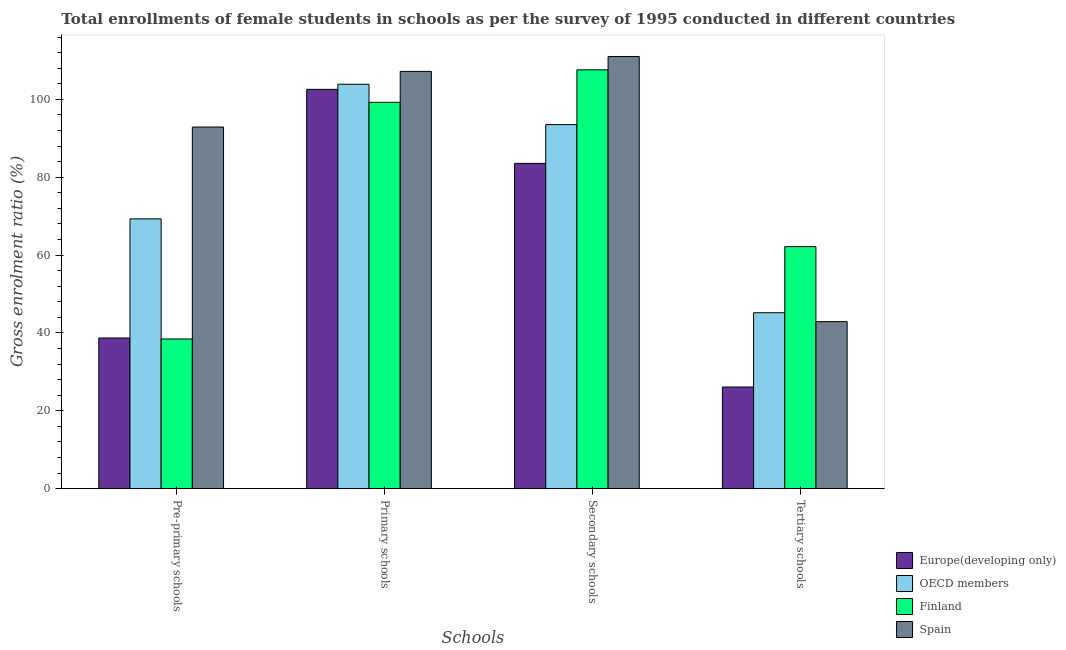Are the number of bars per tick equal to the number of legend labels?
Ensure brevity in your answer.  Yes. Are the number of bars on each tick of the X-axis equal?
Offer a terse response. Yes. How many bars are there on the 2nd tick from the right?
Your answer should be very brief. 4. What is the label of the 3rd group of bars from the left?
Offer a terse response. Secondary schools. What is the gross enrolment ratio(female) in primary schools in OECD members?
Make the answer very short. 103.9. Across all countries, what is the maximum gross enrolment ratio(female) in primary schools?
Ensure brevity in your answer.  107.2. Across all countries, what is the minimum gross enrolment ratio(female) in pre-primary schools?
Offer a terse response. 38.46. In which country was the gross enrolment ratio(female) in pre-primary schools minimum?
Your answer should be very brief. Finland. What is the total gross enrolment ratio(female) in tertiary schools in the graph?
Ensure brevity in your answer.  176.41. What is the difference between the gross enrolment ratio(female) in secondary schools in Finland and that in OECD members?
Your answer should be compact. 14.06. What is the difference between the gross enrolment ratio(female) in secondary schools in Europe(developing only) and the gross enrolment ratio(female) in tertiary schools in Finland?
Make the answer very short. 21.38. What is the average gross enrolment ratio(female) in pre-primary schools per country?
Give a very brief answer. 59.85. What is the difference between the gross enrolment ratio(female) in tertiary schools and gross enrolment ratio(female) in primary schools in Finland?
Ensure brevity in your answer.  -37.06. In how many countries, is the gross enrolment ratio(female) in primary schools greater than 80 %?
Give a very brief answer. 4. What is the ratio of the gross enrolment ratio(female) in tertiary schools in Finland to that in Europe(developing only)?
Make the answer very short. 2.38. What is the difference between the highest and the second highest gross enrolment ratio(female) in primary schools?
Your answer should be compact. 3.3. What is the difference between the highest and the lowest gross enrolment ratio(female) in tertiary schools?
Offer a very short reply. 36.08. Is it the case that in every country, the sum of the gross enrolment ratio(female) in pre-primary schools and gross enrolment ratio(female) in primary schools is greater than the gross enrolment ratio(female) in secondary schools?
Keep it short and to the point. Yes. How many bars are there?
Ensure brevity in your answer.  16. Are all the bars in the graph horizontal?
Ensure brevity in your answer.  No. Does the graph contain any zero values?
Provide a short and direct response. No. Where does the legend appear in the graph?
Your response must be concise. Bottom right. What is the title of the graph?
Offer a terse response. Total enrollments of female students in schools as per the survey of 1995 conducted in different countries. What is the label or title of the X-axis?
Ensure brevity in your answer.  Schools. What is the label or title of the Y-axis?
Your answer should be compact. Gross enrolment ratio (%). What is the Gross enrolment ratio (%) of Europe(developing only) in Pre-primary schools?
Offer a terse response. 38.71. What is the Gross enrolment ratio (%) of OECD members in Pre-primary schools?
Provide a short and direct response. 69.31. What is the Gross enrolment ratio (%) of Finland in Pre-primary schools?
Give a very brief answer. 38.46. What is the Gross enrolment ratio (%) in Spain in Pre-primary schools?
Keep it short and to the point. 92.9. What is the Gross enrolment ratio (%) in Europe(developing only) in Primary schools?
Offer a very short reply. 102.59. What is the Gross enrolment ratio (%) in OECD members in Primary schools?
Provide a short and direct response. 103.9. What is the Gross enrolment ratio (%) of Finland in Primary schools?
Ensure brevity in your answer.  99.25. What is the Gross enrolment ratio (%) of Spain in Primary schools?
Your answer should be compact. 107.2. What is the Gross enrolment ratio (%) in Europe(developing only) in Secondary schools?
Offer a very short reply. 83.57. What is the Gross enrolment ratio (%) of OECD members in Secondary schools?
Your response must be concise. 93.53. What is the Gross enrolment ratio (%) in Finland in Secondary schools?
Your answer should be compact. 107.6. What is the Gross enrolment ratio (%) of Spain in Secondary schools?
Your answer should be very brief. 111.03. What is the Gross enrolment ratio (%) in Europe(developing only) in Tertiary schools?
Your answer should be compact. 26.11. What is the Gross enrolment ratio (%) of OECD members in Tertiary schools?
Your answer should be very brief. 45.19. What is the Gross enrolment ratio (%) in Finland in Tertiary schools?
Ensure brevity in your answer.  62.19. What is the Gross enrolment ratio (%) in Spain in Tertiary schools?
Make the answer very short. 42.92. Across all Schools, what is the maximum Gross enrolment ratio (%) of Europe(developing only)?
Your answer should be very brief. 102.59. Across all Schools, what is the maximum Gross enrolment ratio (%) in OECD members?
Ensure brevity in your answer.  103.9. Across all Schools, what is the maximum Gross enrolment ratio (%) of Finland?
Keep it short and to the point. 107.6. Across all Schools, what is the maximum Gross enrolment ratio (%) in Spain?
Provide a short and direct response. 111.03. Across all Schools, what is the minimum Gross enrolment ratio (%) in Europe(developing only)?
Your answer should be very brief. 26.11. Across all Schools, what is the minimum Gross enrolment ratio (%) of OECD members?
Make the answer very short. 45.19. Across all Schools, what is the minimum Gross enrolment ratio (%) in Finland?
Offer a terse response. 38.46. Across all Schools, what is the minimum Gross enrolment ratio (%) in Spain?
Give a very brief answer. 42.92. What is the total Gross enrolment ratio (%) of Europe(developing only) in the graph?
Provide a succinct answer. 250.98. What is the total Gross enrolment ratio (%) in OECD members in the graph?
Your response must be concise. 311.94. What is the total Gross enrolment ratio (%) of Finland in the graph?
Provide a short and direct response. 307.49. What is the total Gross enrolment ratio (%) of Spain in the graph?
Your answer should be compact. 354.05. What is the difference between the Gross enrolment ratio (%) in Europe(developing only) in Pre-primary schools and that in Primary schools?
Keep it short and to the point. -63.88. What is the difference between the Gross enrolment ratio (%) in OECD members in Pre-primary schools and that in Primary schools?
Offer a terse response. -34.58. What is the difference between the Gross enrolment ratio (%) of Finland in Pre-primary schools and that in Primary schools?
Offer a terse response. -60.79. What is the difference between the Gross enrolment ratio (%) of Spain in Pre-primary schools and that in Primary schools?
Your response must be concise. -14.3. What is the difference between the Gross enrolment ratio (%) of Europe(developing only) in Pre-primary schools and that in Secondary schools?
Offer a very short reply. -44.85. What is the difference between the Gross enrolment ratio (%) of OECD members in Pre-primary schools and that in Secondary schools?
Offer a terse response. -24.22. What is the difference between the Gross enrolment ratio (%) of Finland in Pre-primary schools and that in Secondary schools?
Provide a short and direct response. -69.14. What is the difference between the Gross enrolment ratio (%) of Spain in Pre-primary schools and that in Secondary schools?
Give a very brief answer. -18.13. What is the difference between the Gross enrolment ratio (%) in Europe(developing only) in Pre-primary schools and that in Tertiary schools?
Make the answer very short. 12.6. What is the difference between the Gross enrolment ratio (%) of OECD members in Pre-primary schools and that in Tertiary schools?
Keep it short and to the point. 24.12. What is the difference between the Gross enrolment ratio (%) of Finland in Pre-primary schools and that in Tertiary schools?
Keep it short and to the point. -23.73. What is the difference between the Gross enrolment ratio (%) in Spain in Pre-primary schools and that in Tertiary schools?
Make the answer very short. 49.98. What is the difference between the Gross enrolment ratio (%) in Europe(developing only) in Primary schools and that in Secondary schools?
Keep it short and to the point. 19.02. What is the difference between the Gross enrolment ratio (%) in OECD members in Primary schools and that in Secondary schools?
Your response must be concise. 10.36. What is the difference between the Gross enrolment ratio (%) in Finland in Primary schools and that in Secondary schools?
Your answer should be compact. -8.35. What is the difference between the Gross enrolment ratio (%) in Spain in Primary schools and that in Secondary schools?
Provide a succinct answer. -3.83. What is the difference between the Gross enrolment ratio (%) of Europe(developing only) in Primary schools and that in Tertiary schools?
Offer a terse response. 76.48. What is the difference between the Gross enrolment ratio (%) in OECD members in Primary schools and that in Tertiary schools?
Your response must be concise. 58.7. What is the difference between the Gross enrolment ratio (%) of Finland in Primary schools and that in Tertiary schools?
Your answer should be compact. 37.06. What is the difference between the Gross enrolment ratio (%) in Spain in Primary schools and that in Tertiary schools?
Ensure brevity in your answer.  64.28. What is the difference between the Gross enrolment ratio (%) in Europe(developing only) in Secondary schools and that in Tertiary schools?
Ensure brevity in your answer.  57.45. What is the difference between the Gross enrolment ratio (%) of OECD members in Secondary schools and that in Tertiary schools?
Offer a very short reply. 48.34. What is the difference between the Gross enrolment ratio (%) of Finland in Secondary schools and that in Tertiary schools?
Your response must be concise. 45.41. What is the difference between the Gross enrolment ratio (%) of Spain in Secondary schools and that in Tertiary schools?
Keep it short and to the point. 68.11. What is the difference between the Gross enrolment ratio (%) in Europe(developing only) in Pre-primary schools and the Gross enrolment ratio (%) in OECD members in Primary schools?
Make the answer very short. -65.19. What is the difference between the Gross enrolment ratio (%) in Europe(developing only) in Pre-primary schools and the Gross enrolment ratio (%) in Finland in Primary schools?
Your response must be concise. -60.54. What is the difference between the Gross enrolment ratio (%) in Europe(developing only) in Pre-primary schools and the Gross enrolment ratio (%) in Spain in Primary schools?
Provide a succinct answer. -68.49. What is the difference between the Gross enrolment ratio (%) in OECD members in Pre-primary schools and the Gross enrolment ratio (%) in Finland in Primary schools?
Your answer should be compact. -29.94. What is the difference between the Gross enrolment ratio (%) in OECD members in Pre-primary schools and the Gross enrolment ratio (%) in Spain in Primary schools?
Offer a very short reply. -37.89. What is the difference between the Gross enrolment ratio (%) in Finland in Pre-primary schools and the Gross enrolment ratio (%) in Spain in Primary schools?
Keep it short and to the point. -68.74. What is the difference between the Gross enrolment ratio (%) in Europe(developing only) in Pre-primary schools and the Gross enrolment ratio (%) in OECD members in Secondary schools?
Keep it short and to the point. -54.82. What is the difference between the Gross enrolment ratio (%) of Europe(developing only) in Pre-primary schools and the Gross enrolment ratio (%) of Finland in Secondary schools?
Provide a short and direct response. -68.89. What is the difference between the Gross enrolment ratio (%) of Europe(developing only) in Pre-primary schools and the Gross enrolment ratio (%) of Spain in Secondary schools?
Your answer should be very brief. -72.32. What is the difference between the Gross enrolment ratio (%) of OECD members in Pre-primary schools and the Gross enrolment ratio (%) of Finland in Secondary schools?
Offer a very short reply. -38.29. What is the difference between the Gross enrolment ratio (%) of OECD members in Pre-primary schools and the Gross enrolment ratio (%) of Spain in Secondary schools?
Ensure brevity in your answer.  -41.72. What is the difference between the Gross enrolment ratio (%) of Finland in Pre-primary schools and the Gross enrolment ratio (%) of Spain in Secondary schools?
Offer a very short reply. -72.57. What is the difference between the Gross enrolment ratio (%) of Europe(developing only) in Pre-primary schools and the Gross enrolment ratio (%) of OECD members in Tertiary schools?
Your answer should be very brief. -6.48. What is the difference between the Gross enrolment ratio (%) in Europe(developing only) in Pre-primary schools and the Gross enrolment ratio (%) in Finland in Tertiary schools?
Offer a terse response. -23.48. What is the difference between the Gross enrolment ratio (%) of Europe(developing only) in Pre-primary schools and the Gross enrolment ratio (%) of Spain in Tertiary schools?
Your response must be concise. -4.21. What is the difference between the Gross enrolment ratio (%) in OECD members in Pre-primary schools and the Gross enrolment ratio (%) in Finland in Tertiary schools?
Provide a succinct answer. 7.12. What is the difference between the Gross enrolment ratio (%) of OECD members in Pre-primary schools and the Gross enrolment ratio (%) of Spain in Tertiary schools?
Make the answer very short. 26.39. What is the difference between the Gross enrolment ratio (%) of Finland in Pre-primary schools and the Gross enrolment ratio (%) of Spain in Tertiary schools?
Make the answer very short. -4.46. What is the difference between the Gross enrolment ratio (%) of Europe(developing only) in Primary schools and the Gross enrolment ratio (%) of OECD members in Secondary schools?
Ensure brevity in your answer.  9.05. What is the difference between the Gross enrolment ratio (%) of Europe(developing only) in Primary schools and the Gross enrolment ratio (%) of Finland in Secondary schools?
Ensure brevity in your answer.  -5.01. What is the difference between the Gross enrolment ratio (%) in Europe(developing only) in Primary schools and the Gross enrolment ratio (%) in Spain in Secondary schools?
Offer a terse response. -8.44. What is the difference between the Gross enrolment ratio (%) in OECD members in Primary schools and the Gross enrolment ratio (%) in Finland in Secondary schools?
Your response must be concise. -3.7. What is the difference between the Gross enrolment ratio (%) in OECD members in Primary schools and the Gross enrolment ratio (%) in Spain in Secondary schools?
Offer a terse response. -7.13. What is the difference between the Gross enrolment ratio (%) in Finland in Primary schools and the Gross enrolment ratio (%) in Spain in Secondary schools?
Offer a very short reply. -11.78. What is the difference between the Gross enrolment ratio (%) of Europe(developing only) in Primary schools and the Gross enrolment ratio (%) of OECD members in Tertiary schools?
Make the answer very short. 57.39. What is the difference between the Gross enrolment ratio (%) in Europe(developing only) in Primary schools and the Gross enrolment ratio (%) in Finland in Tertiary schools?
Your answer should be compact. 40.4. What is the difference between the Gross enrolment ratio (%) in Europe(developing only) in Primary schools and the Gross enrolment ratio (%) in Spain in Tertiary schools?
Your answer should be compact. 59.67. What is the difference between the Gross enrolment ratio (%) of OECD members in Primary schools and the Gross enrolment ratio (%) of Finland in Tertiary schools?
Provide a succinct answer. 41.71. What is the difference between the Gross enrolment ratio (%) of OECD members in Primary schools and the Gross enrolment ratio (%) of Spain in Tertiary schools?
Give a very brief answer. 60.98. What is the difference between the Gross enrolment ratio (%) in Finland in Primary schools and the Gross enrolment ratio (%) in Spain in Tertiary schools?
Make the answer very short. 56.33. What is the difference between the Gross enrolment ratio (%) of Europe(developing only) in Secondary schools and the Gross enrolment ratio (%) of OECD members in Tertiary schools?
Offer a very short reply. 38.37. What is the difference between the Gross enrolment ratio (%) of Europe(developing only) in Secondary schools and the Gross enrolment ratio (%) of Finland in Tertiary schools?
Offer a very short reply. 21.38. What is the difference between the Gross enrolment ratio (%) of Europe(developing only) in Secondary schools and the Gross enrolment ratio (%) of Spain in Tertiary schools?
Your answer should be compact. 40.65. What is the difference between the Gross enrolment ratio (%) of OECD members in Secondary schools and the Gross enrolment ratio (%) of Finland in Tertiary schools?
Your answer should be very brief. 31.34. What is the difference between the Gross enrolment ratio (%) of OECD members in Secondary schools and the Gross enrolment ratio (%) of Spain in Tertiary schools?
Your response must be concise. 50.62. What is the difference between the Gross enrolment ratio (%) in Finland in Secondary schools and the Gross enrolment ratio (%) in Spain in Tertiary schools?
Offer a terse response. 64.68. What is the average Gross enrolment ratio (%) of Europe(developing only) per Schools?
Offer a terse response. 62.74. What is the average Gross enrolment ratio (%) in OECD members per Schools?
Provide a short and direct response. 77.98. What is the average Gross enrolment ratio (%) of Finland per Schools?
Offer a very short reply. 76.87. What is the average Gross enrolment ratio (%) in Spain per Schools?
Your response must be concise. 88.51. What is the difference between the Gross enrolment ratio (%) of Europe(developing only) and Gross enrolment ratio (%) of OECD members in Pre-primary schools?
Make the answer very short. -30.6. What is the difference between the Gross enrolment ratio (%) in Europe(developing only) and Gross enrolment ratio (%) in Finland in Pre-primary schools?
Ensure brevity in your answer.  0.25. What is the difference between the Gross enrolment ratio (%) in Europe(developing only) and Gross enrolment ratio (%) in Spain in Pre-primary schools?
Provide a short and direct response. -54.19. What is the difference between the Gross enrolment ratio (%) in OECD members and Gross enrolment ratio (%) in Finland in Pre-primary schools?
Your answer should be compact. 30.86. What is the difference between the Gross enrolment ratio (%) of OECD members and Gross enrolment ratio (%) of Spain in Pre-primary schools?
Your answer should be very brief. -23.59. What is the difference between the Gross enrolment ratio (%) of Finland and Gross enrolment ratio (%) of Spain in Pre-primary schools?
Your answer should be very brief. -54.45. What is the difference between the Gross enrolment ratio (%) of Europe(developing only) and Gross enrolment ratio (%) of OECD members in Primary schools?
Offer a terse response. -1.31. What is the difference between the Gross enrolment ratio (%) in Europe(developing only) and Gross enrolment ratio (%) in Finland in Primary schools?
Keep it short and to the point. 3.34. What is the difference between the Gross enrolment ratio (%) in Europe(developing only) and Gross enrolment ratio (%) in Spain in Primary schools?
Your answer should be compact. -4.61. What is the difference between the Gross enrolment ratio (%) of OECD members and Gross enrolment ratio (%) of Finland in Primary schools?
Ensure brevity in your answer.  4.65. What is the difference between the Gross enrolment ratio (%) of OECD members and Gross enrolment ratio (%) of Spain in Primary schools?
Your answer should be very brief. -3.3. What is the difference between the Gross enrolment ratio (%) of Finland and Gross enrolment ratio (%) of Spain in Primary schools?
Offer a very short reply. -7.95. What is the difference between the Gross enrolment ratio (%) in Europe(developing only) and Gross enrolment ratio (%) in OECD members in Secondary schools?
Your answer should be compact. -9.97. What is the difference between the Gross enrolment ratio (%) in Europe(developing only) and Gross enrolment ratio (%) in Finland in Secondary schools?
Provide a succinct answer. -24.03. What is the difference between the Gross enrolment ratio (%) in Europe(developing only) and Gross enrolment ratio (%) in Spain in Secondary schools?
Offer a terse response. -27.46. What is the difference between the Gross enrolment ratio (%) in OECD members and Gross enrolment ratio (%) in Finland in Secondary schools?
Your answer should be compact. -14.06. What is the difference between the Gross enrolment ratio (%) of OECD members and Gross enrolment ratio (%) of Spain in Secondary schools?
Ensure brevity in your answer.  -17.49. What is the difference between the Gross enrolment ratio (%) in Finland and Gross enrolment ratio (%) in Spain in Secondary schools?
Provide a short and direct response. -3.43. What is the difference between the Gross enrolment ratio (%) of Europe(developing only) and Gross enrolment ratio (%) of OECD members in Tertiary schools?
Your response must be concise. -19.08. What is the difference between the Gross enrolment ratio (%) of Europe(developing only) and Gross enrolment ratio (%) of Finland in Tertiary schools?
Keep it short and to the point. -36.08. What is the difference between the Gross enrolment ratio (%) in Europe(developing only) and Gross enrolment ratio (%) in Spain in Tertiary schools?
Your response must be concise. -16.81. What is the difference between the Gross enrolment ratio (%) in OECD members and Gross enrolment ratio (%) in Finland in Tertiary schools?
Ensure brevity in your answer.  -16.99. What is the difference between the Gross enrolment ratio (%) in OECD members and Gross enrolment ratio (%) in Spain in Tertiary schools?
Make the answer very short. 2.28. What is the difference between the Gross enrolment ratio (%) in Finland and Gross enrolment ratio (%) in Spain in Tertiary schools?
Your answer should be compact. 19.27. What is the ratio of the Gross enrolment ratio (%) in Europe(developing only) in Pre-primary schools to that in Primary schools?
Offer a very short reply. 0.38. What is the ratio of the Gross enrolment ratio (%) of OECD members in Pre-primary schools to that in Primary schools?
Your answer should be compact. 0.67. What is the ratio of the Gross enrolment ratio (%) in Finland in Pre-primary schools to that in Primary schools?
Your answer should be compact. 0.39. What is the ratio of the Gross enrolment ratio (%) in Spain in Pre-primary schools to that in Primary schools?
Offer a very short reply. 0.87. What is the ratio of the Gross enrolment ratio (%) in Europe(developing only) in Pre-primary schools to that in Secondary schools?
Keep it short and to the point. 0.46. What is the ratio of the Gross enrolment ratio (%) in OECD members in Pre-primary schools to that in Secondary schools?
Your response must be concise. 0.74. What is the ratio of the Gross enrolment ratio (%) in Finland in Pre-primary schools to that in Secondary schools?
Your answer should be very brief. 0.36. What is the ratio of the Gross enrolment ratio (%) in Spain in Pre-primary schools to that in Secondary schools?
Your answer should be compact. 0.84. What is the ratio of the Gross enrolment ratio (%) of Europe(developing only) in Pre-primary schools to that in Tertiary schools?
Your answer should be compact. 1.48. What is the ratio of the Gross enrolment ratio (%) in OECD members in Pre-primary schools to that in Tertiary schools?
Ensure brevity in your answer.  1.53. What is the ratio of the Gross enrolment ratio (%) in Finland in Pre-primary schools to that in Tertiary schools?
Ensure brevity in your answer.  0.62. What is the ratio of the Gross enrolment ratio (%) of Spain in Pre-primary schools to that in Tertiary schools?
Ensure brevity in your answer.  2.16. What is the ratio of the Gross enrolment ratio (%) of Europe(developing only) in Primary schools to that in Secondary schools?
Your answer should be compact. 1.23. What is the ratio of the Gross enrolment ratio (%) in OECD members in Primary schools to that in Secondary schools?
Offer a terse response. 1.11. What is the ratio of the Gross enrolment ratio (%) of Finland in Primary schools to that in Secondary schools?
Make the answer very short. 0.92. What is the ratio of the Gross enrolment ratio (%) in Spain in Primary schools to that in Secondary schools?
Ensure brevity in your answer.  0.97. What is the ratio of the Gross enrolment ratio (%) in Europe(developing only) in Primary schools to that in Tertiary schools?
Your response must be concise. 3.93. What is the ratio of the Gross enrolment ratio (%) of OECD members in Primary schools to that in Tertiary schools?
Provide a short and direct response. 2.3. What is the ratio of the Gross enrolment ratio (%) in Finland in Primary schools to that in Tertiary schools?
Keep it short and to the point. 1.6. What is the ratio of the Gross enrolment ratio (%) of Spain in Primary schools to that in Tertiary schools?
Your answer should be compact. 2.5. What is the ratio of the Gross enrolment ratio (%) in Europe(developing only) in Secondary schools to that in Tertiary schools?
Your answer should be compact. 3.2. What is the ratio of the Gross enrolment ratio (%) in OECD members in Secondary schools to that in Tertiary schools?
Provide a short and direct response. 2.07. What is the ratio of the Gross enrolment ratio (%) in Finland in Secondary schools to that in Tertiary schools?
Your response must be concise. 1.73. What is the ratio of the Gross enrolment ratio (%) in Spain in Secondary schools to that in Tertiary schools?
Make the answer very short. 2.59. What is the difference between the highest and the second highest Gross enrolment ratio (%) in Europe(developing only)?
Make the answer very short. 19.02. What is the difference between the highest and the second highest Gross enrolment ratio (%) in OECD members?
Provide a short and direct response. 10.36. What is the difference between the highest and the second highest Gross enrolment ratio (%) in Finland?
Keep it short and to the point. 8.35. What is the difference between the highest and the second highest Gross enrolment ratio (%) of Spain?
Keep it short and to the point. 3.83. What is the difference between the highest and the lowest Gross enrolment ratio (%) in Europe(developing only)?
Provide a short and direct response. 76.48. What is the difference between the highest and the lowest Gross enrolment ratio (%) of OECD members?
Make the answer very short. 58.7. What is the difference between the highest and the lowest Gross enrolment ratio (%) of Finland?
Offer a very short reply. 69.14. What is the difference between the highest and the lowest Gross enrolment ratio (%) of Spain?
Your answer should be compact. 68.11. 